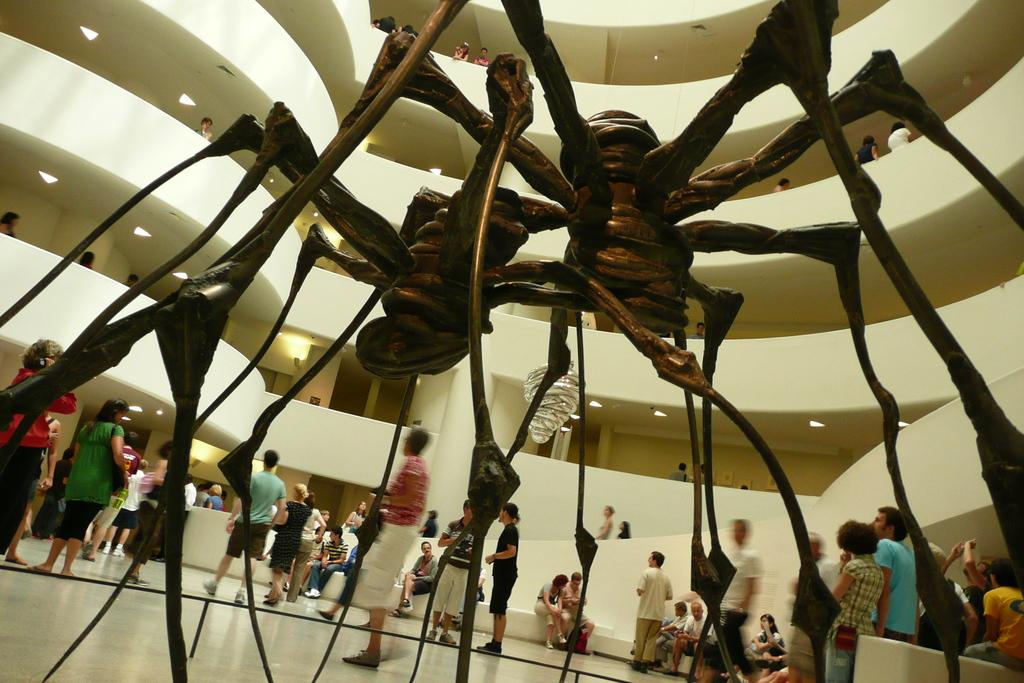What shapes can be seen in the image? There are things in the shape of spiders. Can you describe the appearance of these spider-shaped objects? Unfortunately, the facts provided do not give any details about the appearance of the spider-shaped objects. However, we can confirm that they are in the shape of spiders. What color are the crayons in the image? There are no crayons present in the image; it only features things in the shape of spiders. 